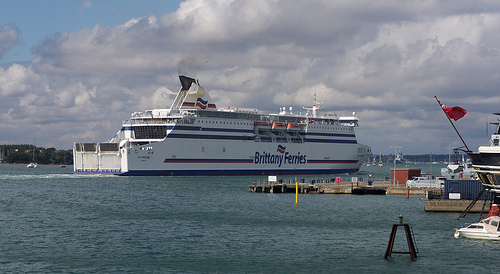What are the details about the ship in the image? The ship in the image is a large white ferry with the words 'Brittany Ferries' written on its side in blue letters. It has several decks and windows, and it appears to be docked or cruising close to a port. Can you describe some other prominent features visible on the ship? Yes, aside from the 'Brittany Ferries' label, the ship features a large funnel with a distinct red and blue design, rows of lifeboats, and numerous antennae and communication equipment atop the bridge. The ship has multiple levels, with open decks for passengers to enjoy the view. 